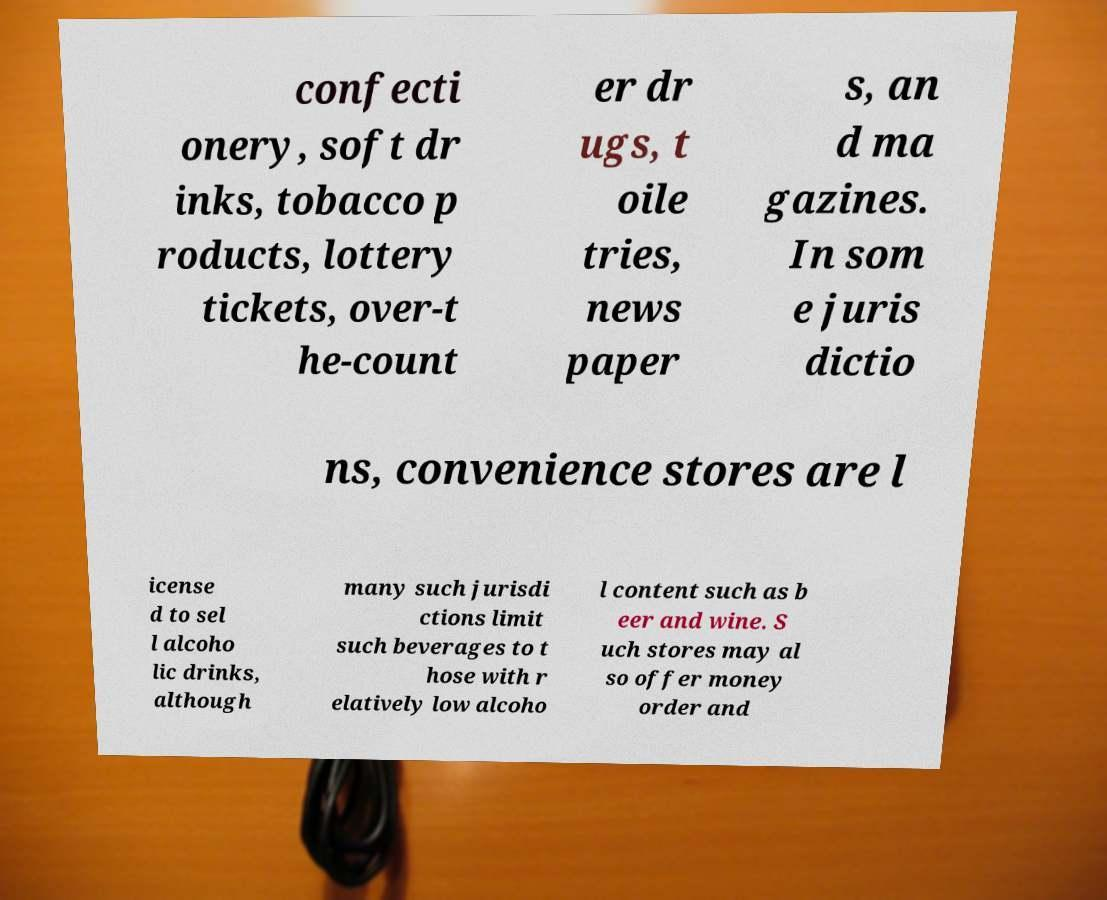Can you read and provide the text displayed in the image?This photo seems to have some interesting text. Can you extract and type it out for me? confecti onery, soft dr inks, tobacco p roducts, lottery tickets, over-t he-count er dr ugs, t oile tries, news paper s, an d ma gazines. In som e juris dictio ns, convenience stores are l icense d to sel l alcoho lic drinks, although many such jurisdi ctions limit such beverages to t hose with r elatively low alcoho l content such as b eer and wine. S uch stores may al so offer money order and 